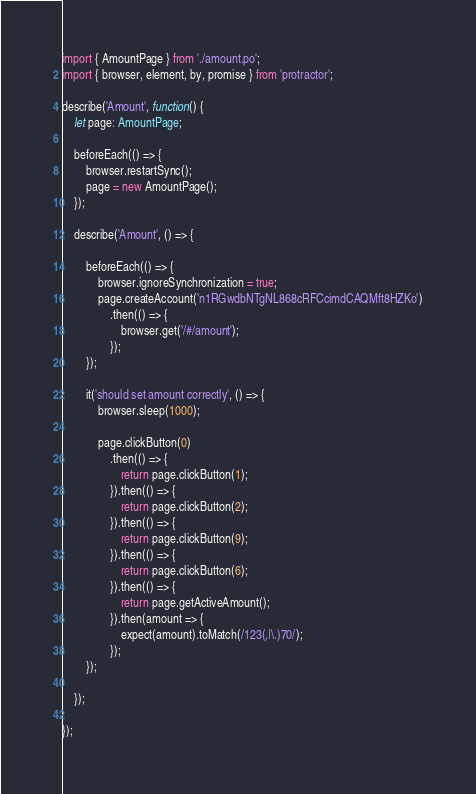Convert code to text. <code><loc_0><loc_0><loc_500><loc_500><_TypeScript_>import { AmountPage } from './amount.po';
import { browser, element, by, promise } from 'protractor';

describe('Amount', function() {
    let page: AmountPage;

    beforeEach(() => {
        browser.restartSync();
        page = new AmountPage();
    });

    describe('Amount', () => {

        beforeEach(() => {
            browser.ignoreSynchronization = true;
            page.createAccount('n1RGwdbNTgNL868cRFCcimdCAQMft8HZKo')
                .then(() => {                    
                    browser.get('/#/amount');   
                });         
        });

        it('should set amount correctly', () => {
            browser.sleep(1000);

            page.clickButton(0)
                .then(() => {
                    return page.clickButton(1);
                }).then(() => {
                    return page.clickButton(2);
                }).then(() => {
                    return page.clickButton(9);
                }).then(() => {
                    return page.clickButton(6);
                }).then(() => {
                    return page.getActiveAmount();
                }).then(amount => {
                    expect(amount).toMatch(/123(,|\.)70/);
                });                
        });

    });

});</code> 